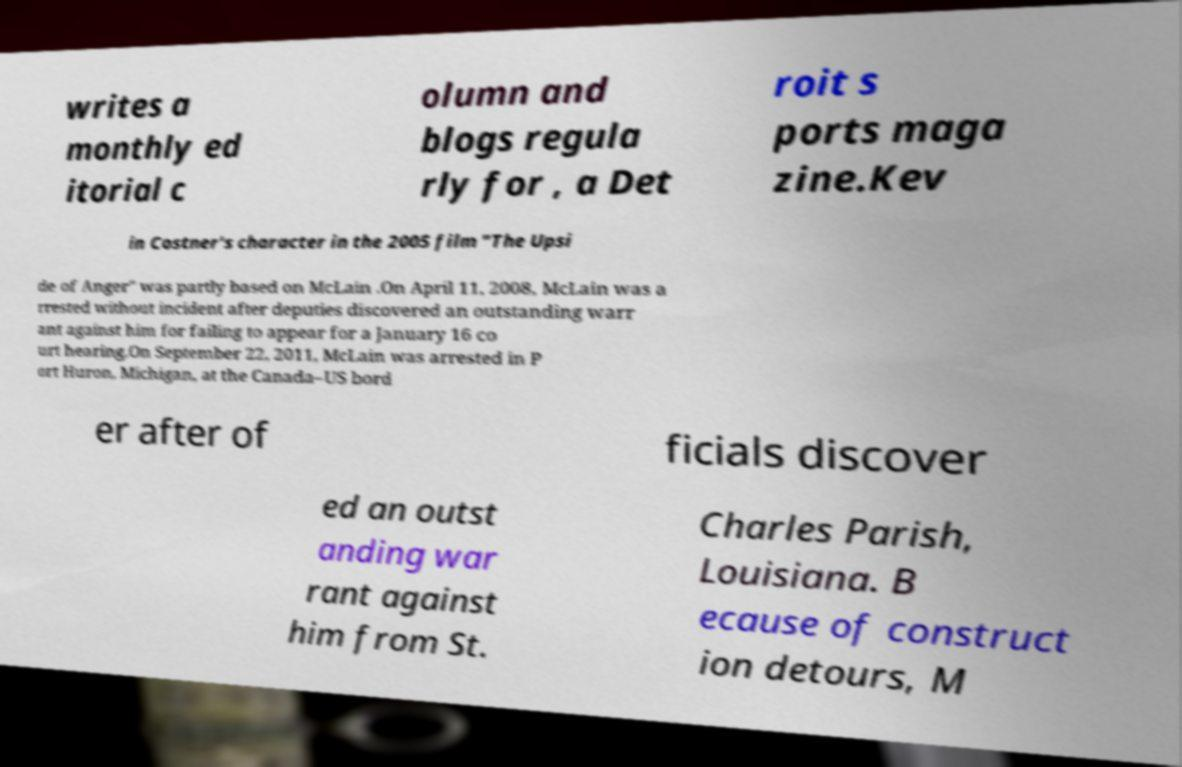Can you read and provide the text displayed in the image?This photo seems to have some interesting text. Can you extract and type it out for me? writes a monthly ed itorial c olumn and blogs regula rly for , a Det roit s ports maga zine.Kev in Costner's character in the 2005 film "The Upsi de of Anger" was partly based on McLain .On April 11, 2008, McLain was a rrested without incident after deputies discovered an outstanding warr ant against him for failing to appear for a January 16 co urt hearing.On September 22, 2011, McLain was arrested in P ort Huron, Michigan, at the Canada–US bord er after of ficials discover ed an outst anding war rant against him from St. Charles Parish, Louisiana. B ecause of construct ion detours, M 